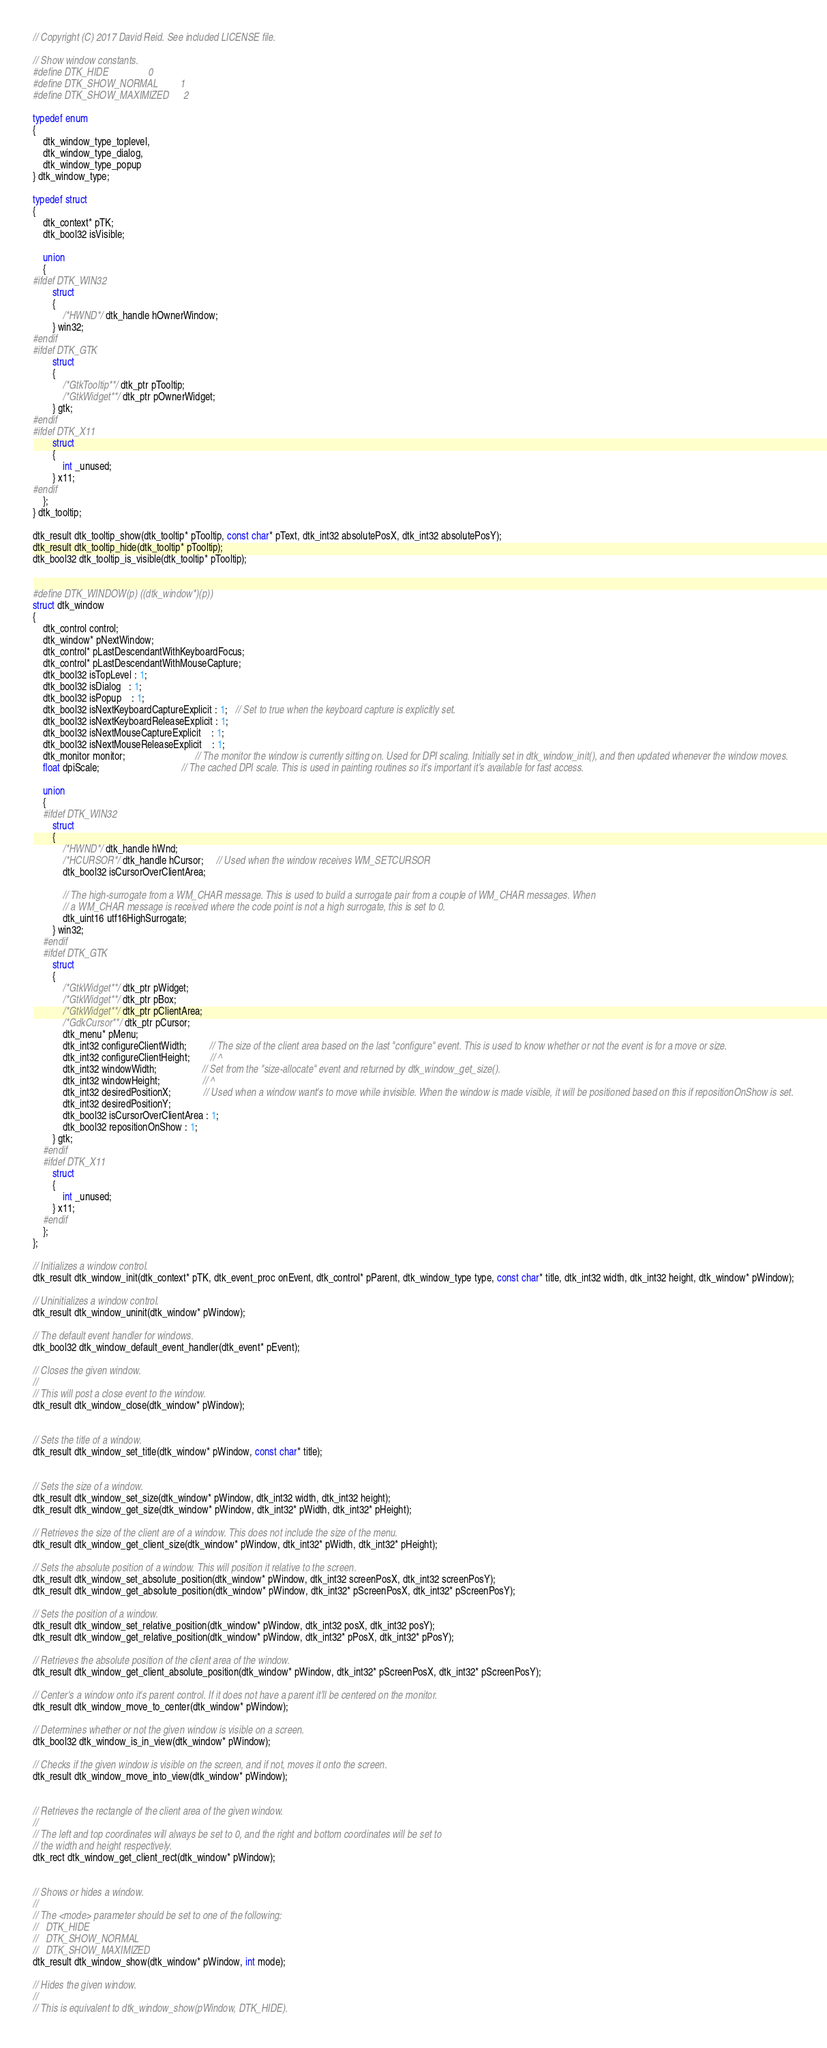Convert code to text. <code><loc_0><loc_0><loc_500><loc_500><_C_>// Copyright (C) 2017 David Reid. See included LICENSE file.

// Show window constants.
#define DTK_HIDE                0
#define DTK_SHOW_NORMAL         1
#define DTK_SHOW_MAXIMIZED      2

typedef enum
{
    dtk_window_type_toplevel,
    dtk_window_type_dialog,
    dtk_window_type_popup
} dtk_window_type;

typedef struct
{
    dtk_context* pTK;
    dtk_bool32 isVisible;

    union
    {
#ifdef DTK_WIN32
        struct
        {
            /*HWND*/ dtk_handle hOwnerWindow;
        } win32;
#endif
#ifdef DTK_GTK
        struct
        {
            /*GtkTooltip**/ dtk_ptr pTooltip;
            /*GtkWidget**/ dtk_ptr pOwnerWidget;
        } gtk;
#endif
#ifdef DTK_X11
        struct
        {
            int _unused;
        } x11;
#endif
    };
} dtk_tooltip;

dtk_result dtk_tooltip_show(dtk_tooltip* pTooltip, const char* pText, dtk_int32 absolutePosX, dtk_int32 absolutePosY);
dtk_result dtk_tooltip_hide(dtk_tooltip* pTooltip);
dtk_bool32 dtk_tooltip_is_visible(dtk_tooltip* pTooltip);


#define DTK_WINDOW(p) ((dtk_window*)(p))
struct dtk_window
{
    dtk_control control;
    dtk_window* pNextWindow;
    dtk_control* pLastDescendantWithKeyboardFocus;
    dtk_control* pLastDescendantWithMouseCapture;
    dtk_bool32 isTopLevel : 1;
    dtk_bool32 isDialog   : 1;
    dtk_bool32 isPopup    : 1;
    dtk_bool32 isNextKeyboardCaptureExplicit : 1;   // Set to true when the keyboard capture is explicitly set.
    dtk_bool32 isNextKeyboardReleaseExplicit : 1;
    dtk_bool32 isNextMouseCaptureExplicit    : 1;
    dtk_bool32 isNextMouseReleaseExplicit    : 1;
    dtk_monitor monitor;                            // The monitor the window is currently sitting on. Used for DPI scaling. Initially set in dtk_window_init(), and then updated whenever the window moves.
    float dpiScale;                                 // The cached DPI scale. This is used in painting routines so it's important it's available for fast access.

    union
    {
    #ifdef DTK_WIN32
        struct
        {
            /*HWND*/ dtk_handle hWnd;
            /*HCURSOR*/ dtk_handle hCursor;     // Used when the window receives WM_SETCURSOR
            dtk_bool32 isCursorOverClientArea;

            // The high-surrogate from a WM_CHAR message. This is used to build a surrogate pair from a couple of WM_CHAR messages. When
            // a WM_CHAR message is received where the code point is not a high surrogate, this is set to 0.
            dtk_uint16 utf16HighSurrogate;
        } win32;
    #endif
    #ifdef DTK_GTK
        struct
        {
            /*GtkWidget**/ dtk_ptr pWidget;
            /*GtkWidget**/ dtk_ptr pBox;
            /*GtkWidget**/ dtk_ptr pClientArea;
            /*GdkCursor**/ dtk_ptr pCursor;
            dtk_menu* pMenu;
            dtk_int32 configureClientWidth;         // The size of the client area based on the last "configure" event. This is used to know whether or not the event is for a move or size.
            dtk_int32 configureClientHeight;        // ^
            dtk_int32 windowWidth;                  // Set from the "size-allocate" event and returned by dtk_window_get_size().
            dtk_int32 windowHeight;                 // ^
            dtk_int32 desiredPositionX;             // Used when a window want's to move while invisible. When the window is made visible, it will be positioned based on this if repositionOnShow is set.
            dtk_int32 desiredPositionY; 
            dtk_bool32 isCursorOverClientArea : 1;
            dtk_bool32 repositionOnShow : 1;
        } gtk;
    #endif
    #ifdef DTK_X11
        struct
        {
            int _unused;
        } x11;
    #endif
    };
};

// Initializes a window control.
dtk_result dtk_window_init(dtk_context* pTK, dtk_event_proc onEvent, dtk_control* pParent, dtk_window_type type, const char* title, dtk_int32 width, dtk_int32 height, dtk_window* pWindow);

// Uninitializes a window control.
dtk_result dtk_window_uninit(dtk_window* pWindow);

// The default event handler for windows.
dtk_bool32 dtk_window_default_event_handler(dtk_event* pEvent);

// Closes the given window.
//
// This will post a close event to the window.
dtk_result dtk_window_close(dtk_window* pWindow);


// Sets the title of a window.
dtk_result dtk_window_set_title(dtk_window* pWindow, const char* title);


// Sets the size of a window.
dtk_result dtk_window_set_size(dtk_window* pWindow, dtk_int32 width, dtk_int32 height);
dtk_result dtk_window_get_size(dtk_window* pWindow, dtk_int32* pWidth, dtk_int32* pHeight);

// Retrieves the size of the client are of a window. This does not include the size of the menu.
dtk_result dtk_window_get_client_size(dtk_window* pWindow, dtk_int32* pWidth, dtk_int32* pHeight);

// Sets the absolute position of a window. This will position it relative to the screen.
dtk_result dtk_window_set_absolute_position(dtk_window* pWindow, dtk_int32 screenPosX, dtk_int32 screenPosY);
dtk_result dtk_window_get_absolute_position(dtk_window* pWindow, dtk_int32* pScreenPosX, dtk_int32* pScreenPosY);

// Sets the position of a window.
dtk_result dtk_window_set_relative_position(dtk_window* pWindow, dtk_int32 posX, dtk_int32 posY);
dtk_result dtk_window_get_relative_position(dtk_window* pWindow, dtk_int32* pPosX, dtk_int32* pPosY);

// Retrieves the absolute position of the client area of the window.
dtk_result dtk_window_get_client_absolute_position(dtk_window* pWindow, dtk_int32* pScreenPosX, dtk_int32* pScreenPosY);

// Center's a window onto it's parent control. If it does not have a parent it'll be centered on the monitor.
dtk_result dtk_window_move_to_center(dtk_window* pWindow);

// Determines whether or not the given window is visible on a screen.
dtk_bool32 dtk_window_is_in_view(dtk_window* pWindow);

// Checks if the given window is visible on the screen, and if not, moves it onto the screen.
dtk_result dtk_window_move_into_view(dtk_window* pWindow);


// Retrieves the rectangle of the client area of the given window.
//
// The left and top coordinates will always be set to 0, and the right and bottom coordinates will be set to
// the width and height respectively.
dtk_rect dtk_window_get_client_rect(dtk_window* pWindow);


// Shows or hides a window.
//
// The <mode> parameter should be set to one of the following:
//   DTK_HIDE
//   DTK_SHOW_NORMAL
//   DTK_SHOW_MAXIMIZED
dtk_result dtk_window_show(dtk_window* pWindow, int mode);

// Hides the given window.
//
// This is equivalent to dtk_window_show(pWindow, DTK_HIDE).</code> 